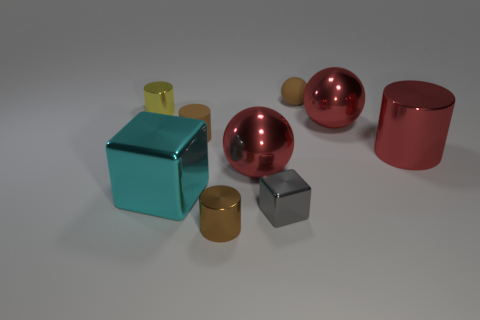Subtract all red spheres. How many spheres are left? 1 Subtract 1 cylinders. How many cylinders are left? 3 Subtract all brown cylinders. How many cylinders are left? 2 Add 1 small purple spheres. How many objects exist? 10 Subtract all cubes. How many objects are left? 7 Subtract all cyan blocks. How many green spheres are left? 0 Subtract all tiny gray rubber blocks. Subtract all yellow things. How many objects are left? 8 Add 1 brown balls. How many brown balls are left? 2 Add 9 green balls. How many green balls exist? 9 Subtract 1 red spheres. How many objects are left? 8 